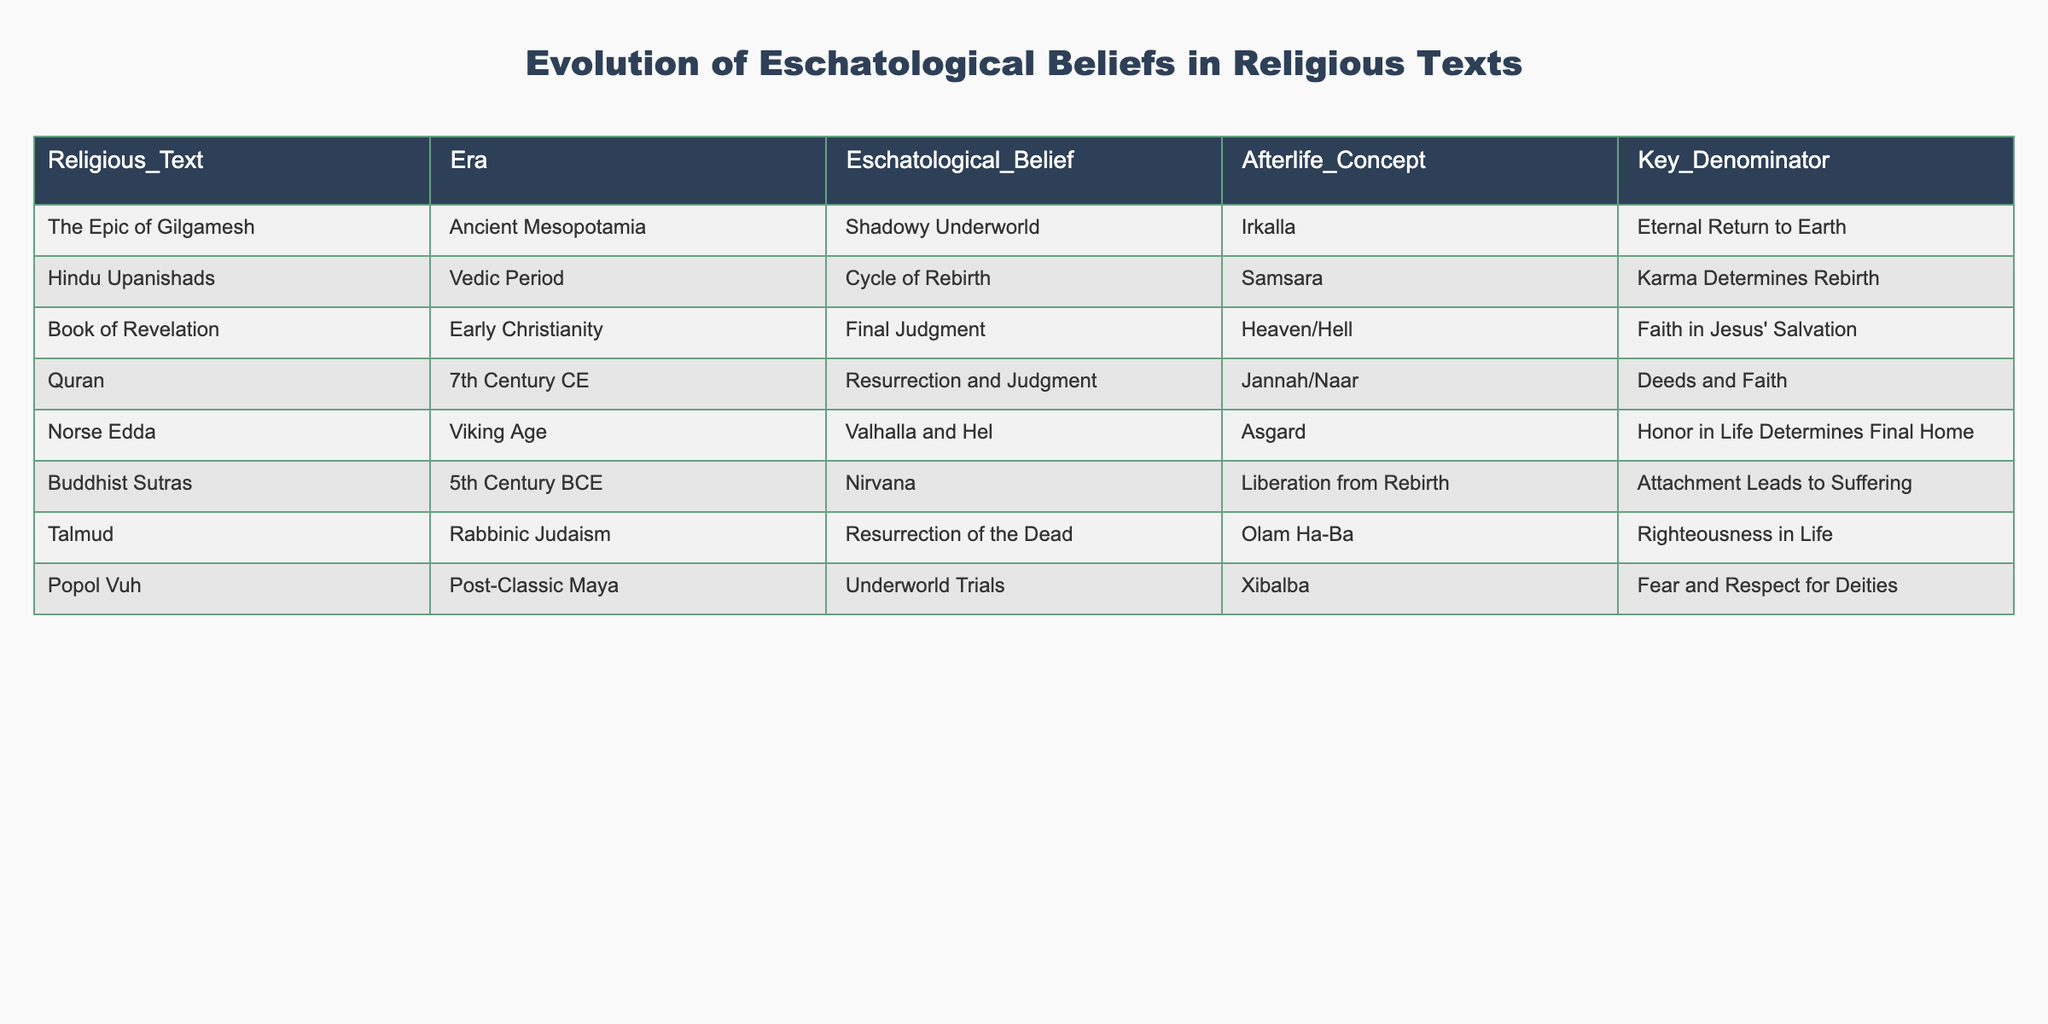What is the eschatological belief associated with the Book of Revelation? The table indicates that the eschatological belief from the Book of Revelation is the Final Judgment. This is found directly in the column labeled "Eschatological_Belief" corresponding to "Book of Revelation."
Answer: Final Judgment Which afterlife concept is linked to Hindu Upanishads? According to the table, the afterlife concept associated with the Hindu Upanishads is Samsara, as stated in the "Afterlife_Concept" column for that religious text.
Answer: Samsara Is there an eschatological belief that describes an eternal return to Earth? Yes, the table shows that the eschatological belief in the Epic of Gilgamesh includes the concept of eternal return to Earth, which is explicitly listed in the "Eschatological_Belief" column.
Answer: Yes How many different afterlife concepts are mentioned in the table? To find the total number of unique afterlife concepts, we count the distinct entries under the "Afterlife_Concept" column. The concepts listed are Irkalla, Samsara, Heaven/Hell, Jannah/Naar, Asgard, Liberation from Rebirth, Olam Ha-Ba, and Xibalba, totaling 8 unique concepts.
Answer: 8 What do the eschatological beliefs from the Norse Edda and the Quran have in common? Both the Norse Edda and the Quran encompass concepts of judgment and the final fate of individuals. By examining the details, the Norse Edda relates to honor in life determining the final home, while the Quran emphasizes deeds and faith as determinants for Jannah or Naar. Both incorporate a moral dimension to their beliefs about the afterlife.
Answer: Judgment and moral dimension Which text reflects a belief in resurrection? The table lists the Talmud under the column "Eschatological_Belief," indicating a belief in the Resurrection of the Dead. This directly answers the question based on the information in the table.
Answer: Talmud What is the key denominator for the eschatological belief in the Buddhist Sutras? The key denominator specified in relation to the eschatological belief in the Buddhist Sutras is "Attachment Leads to Suffering," as outlined in the "Key_Denominator" column for that text.
Answer: Attachment Leads to Suffering Are the concepts of Jannah and Naar mentioned in the same religious text? Yes, the concepts of Jannah and Naar are both found in the Quran, which includes these terms in describing the afterlife. This system of belief highlights the significance of deeds and faith.
Answer: Yes What distinguishes the eschatological belief of the post-Classic Maya in the Popol Vuh from those of Early Christianity? The Popol Vuh emphasizes Underworld Trials, which speaks to a cultural context of fear and respect for deities, whereas the Book of Revelation focuses on Final Judgment based on faith in Jesus' salvation. Thus, the core beliefs and theological implications differ significantly.
Answer: Distinct beliefs based on cultural contexts 